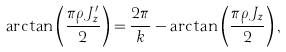Convert formula to latex. <formula><loc_0><loc_0><loc_500><loc_500>\arctan \left ( \frac { \pi \rho J ^ { \prime } _ { z } } { 2 } \right ) = \frac { 2 \pi } { k } - \arctan \left ( \frac { \pi \rho J _ { z } } { 2 } \right ) ,</formula> 